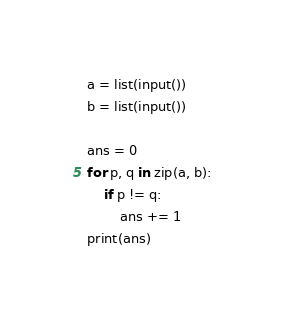<code> <loc_0><loc_0><loc_500><loc_500><_Python_>a = list(input())
b = list(input())

ans = 0
for p, q in zip(a, b):
    if p != q:
        ans += 1
print(ans)
</code> 